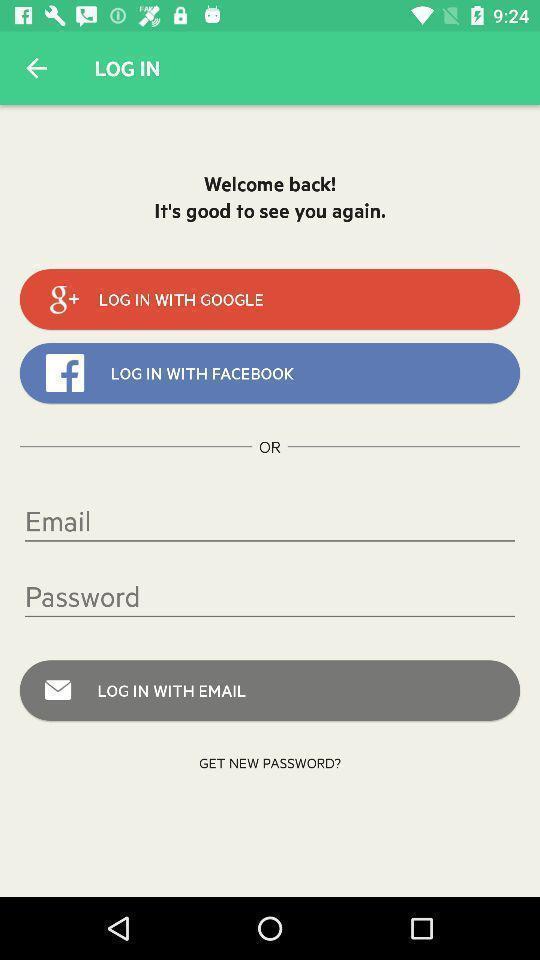Please provide a description for this image. Page displaying the ways to login. 